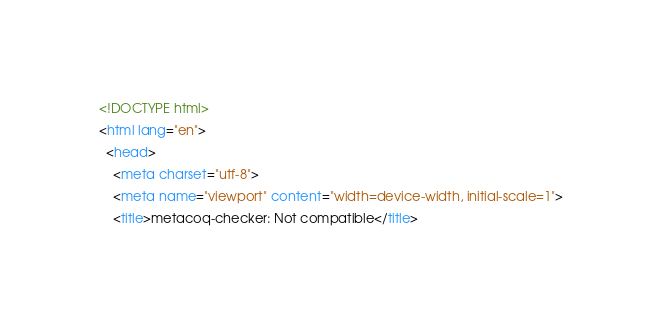Convert code to text. <code><loc_0><loc_0><loc_500><loc_500><_HTML_><!DOCTYPE html>
<html lang="en">
  <head>
    <meta charset="utf-8">
    <meta name="viewport" content="width=device-width, initial-scale=1">
    <title>metacoq-checker: Not compatible</title></code> 